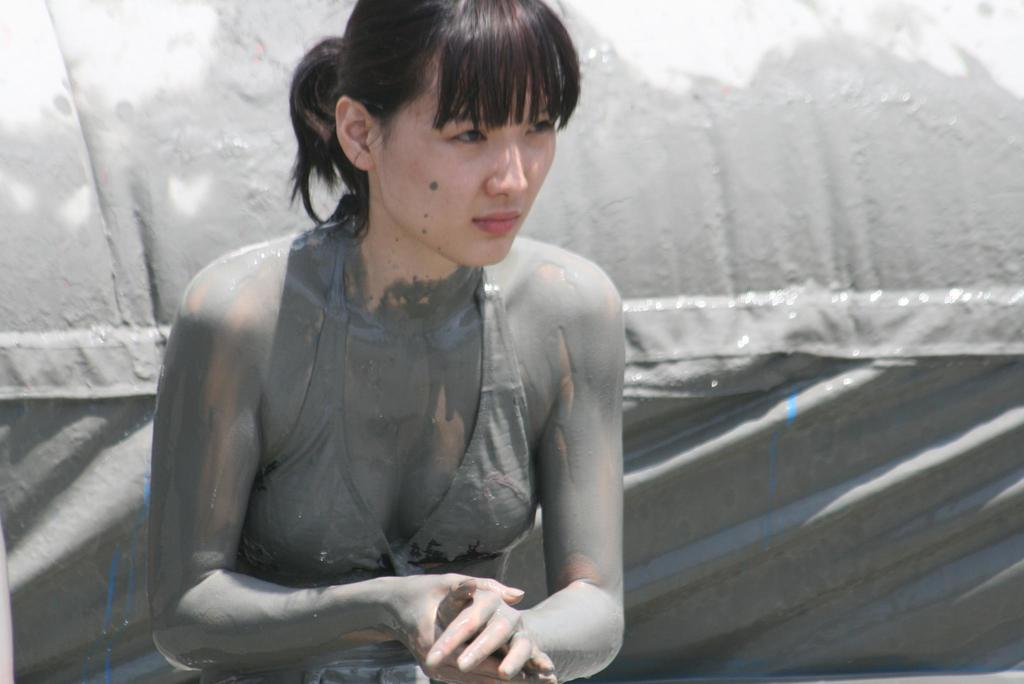Who is present in the image? There is a lady in the image. What can be seen behind the lady? There is a background in the image. What type of bells can be heard ringing in the image? There are no bells present in the image, and therefore no sound can be heard. 